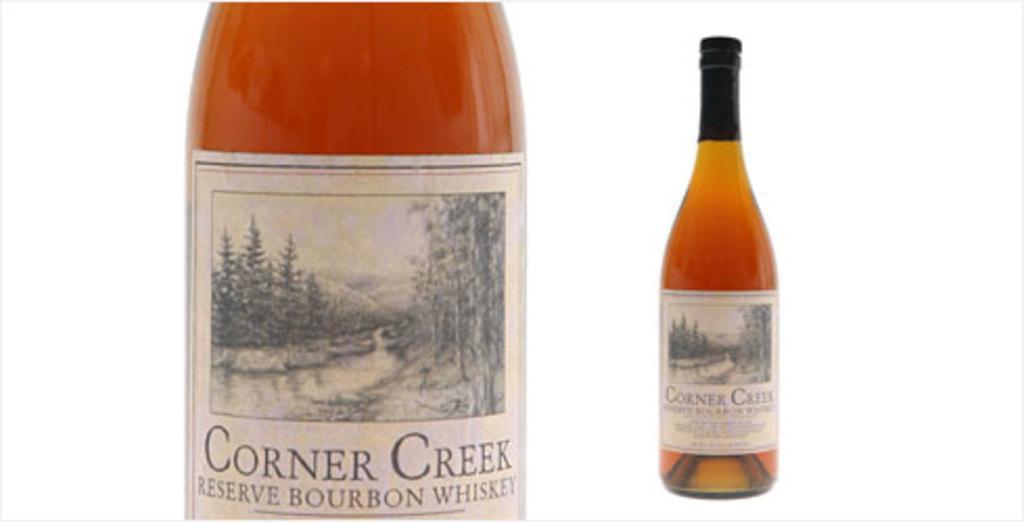Could you give a brief overview of what you see in this image? In this we can observe a whiskey bottle. We can observe a white color sticker around this bottle. 